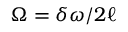<formula> <loc_0><loc_0><loc_500><loc_500>\Omega = \delta \omega / 2 \ell</formula> 